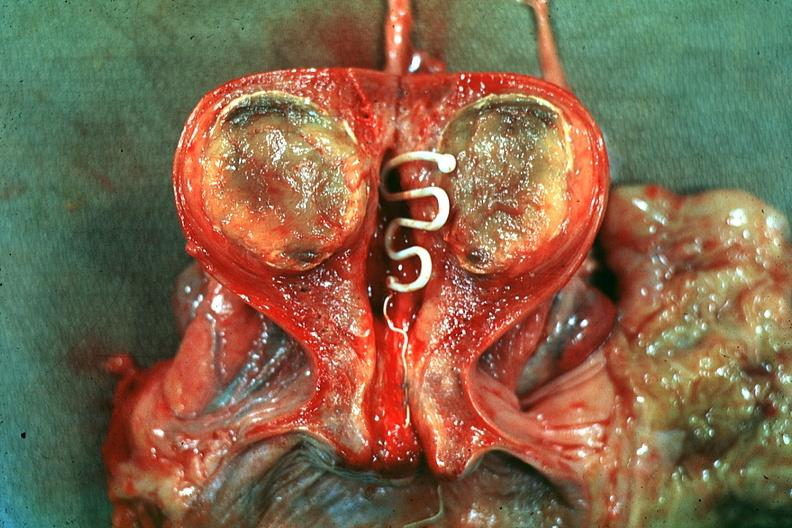what is present?
Answer the question using a single word or phrase. Intrauterine contraceptive device 